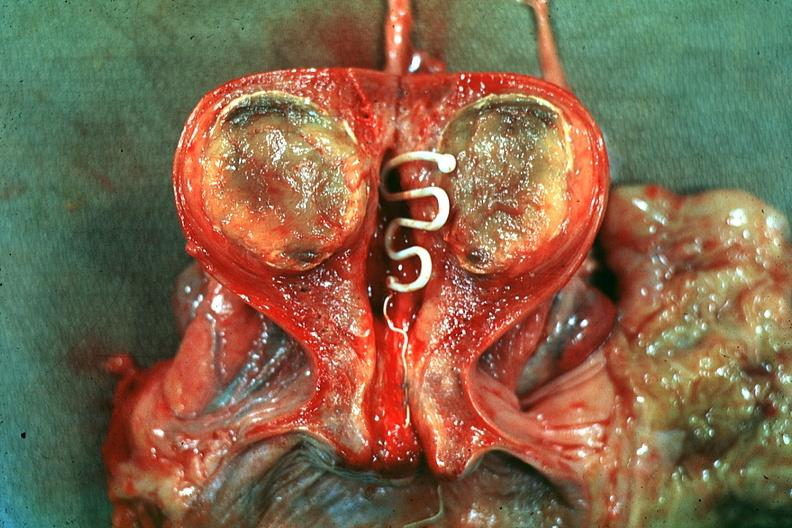what is present?
Answer the question using a single word or phrase. Intrauterine contraceptive device 